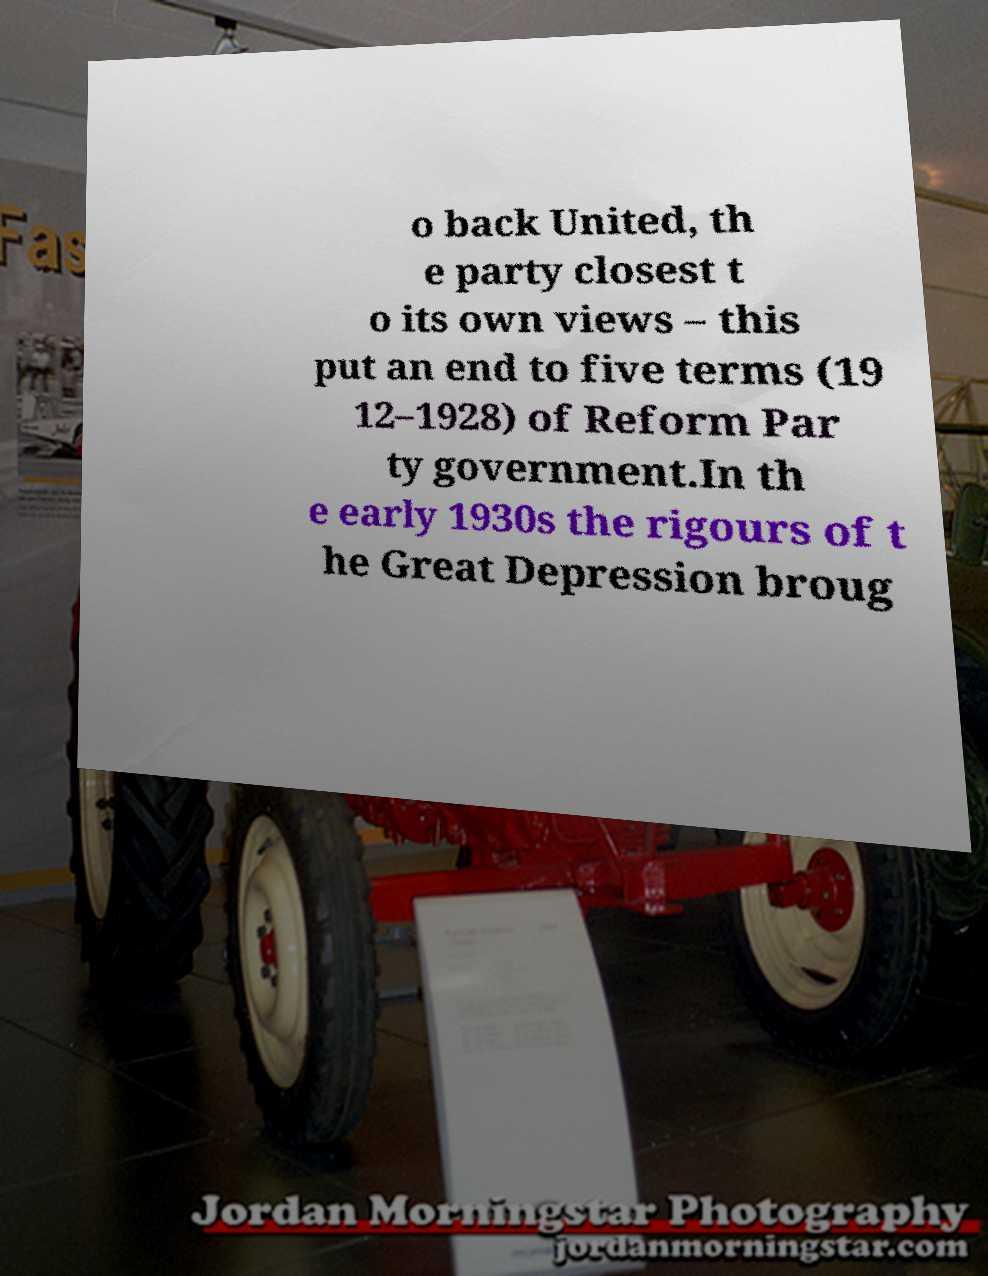Can you read and provide the text displayed in the image?This photo seems to have some interesting text. Can you extract and type it out for me? o back United, th e party closest t o its own views – this put an end to five terms (19 12–1928) of Reform Par ty government.In th e early 1930s the rigours of t he Great Depression broug 